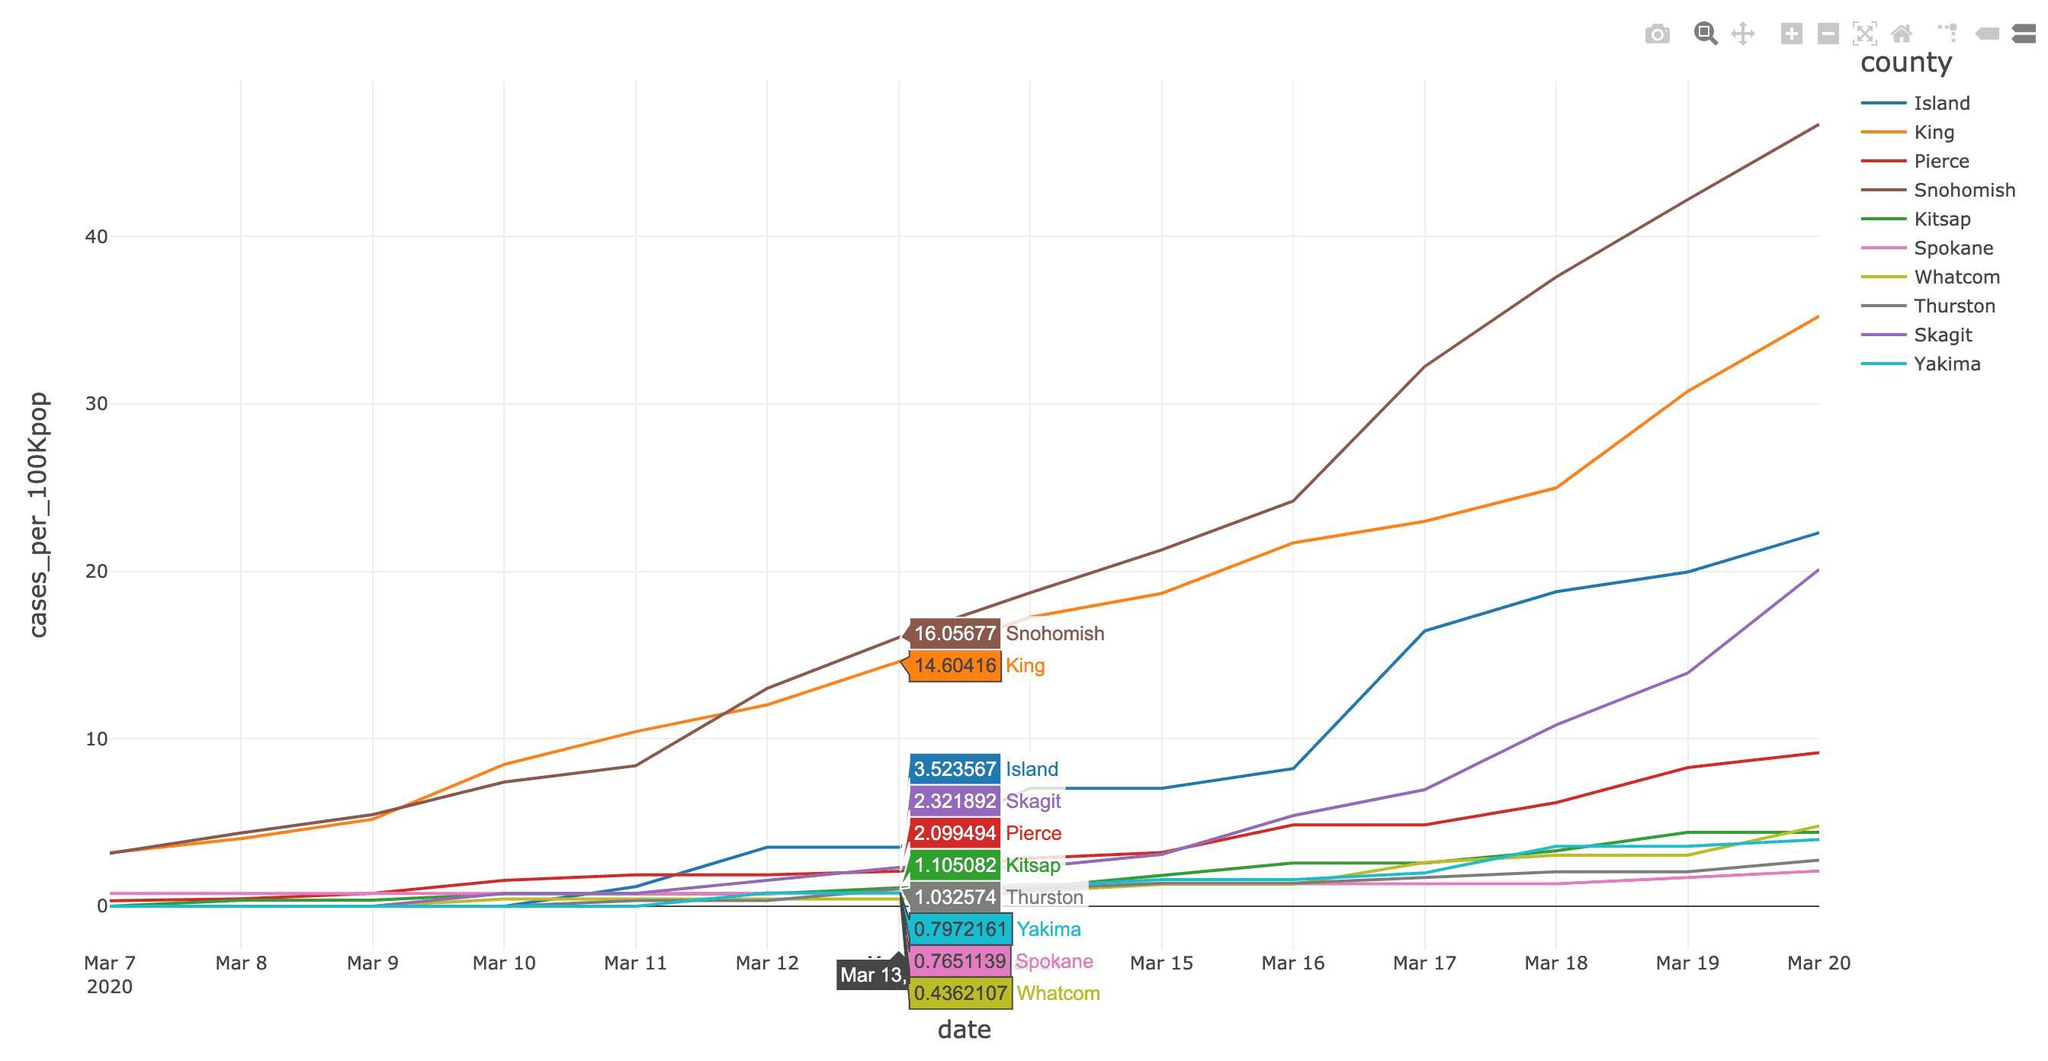After which date first rapid increase in no of cases reported in "King"?
Answer the question with a short phrase. Mar 9 What is the no of cases in the red coloured region? 2.099494 What is the color code given to Pierce- yellow, red, green, orange? red Which region reported highest no of cases per 100Kpop on Mar 11? King Which is the region with second least no of cases reported per 100Kpop? Spokane Which is the region coloured in grey? Thurston What is the difference between the cases in Snohomish and King? 1.45261 What is the color code given to King- yellow, red, green, orange? orange Which is the region with second highest no of cases reported per 100Kpop? King What is the no of cases in the orange coloured region? 14.60416 